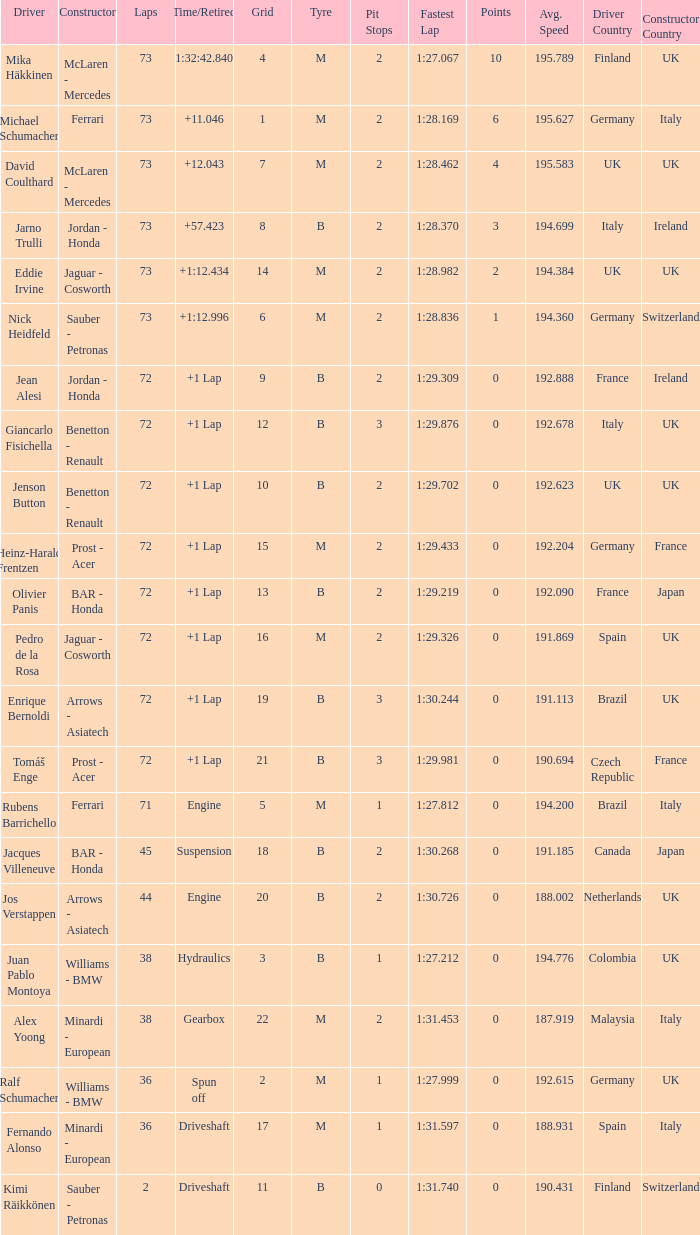Who is the constructor when the laps is more than 72 and the driver is eddie irvine? Jaguar - Cosworth. 